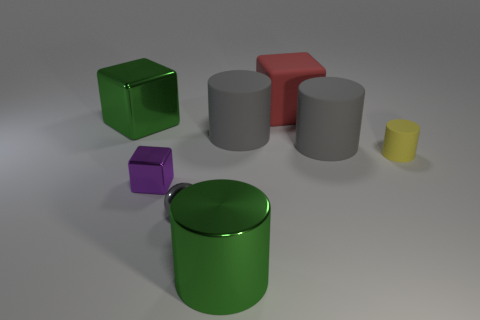Subtract all small metal blocks. How many blocks are left? 2 Add 1 small yellow rubber cylinders. How many objects exist? 9 Subtract all blue cubes. How many gray cylinders are left? 2 Subtract all yellow cylinders. How many cylinders are left? 3 Add 1 large green objects. How many large green objects exist? 3 Subtract 0 purple balls. How many objects are left? 8 Subtract all blocks. How many objects are left? 5 Subtract 1 cylinders. How many cylinders are left? 3 Subtract all blue cylinders. Subtract all purple blocks. How many cylinders are left? 4 Subtract all purple metallic blocks. Subtract all tiny objects. How many objects are left? 4 